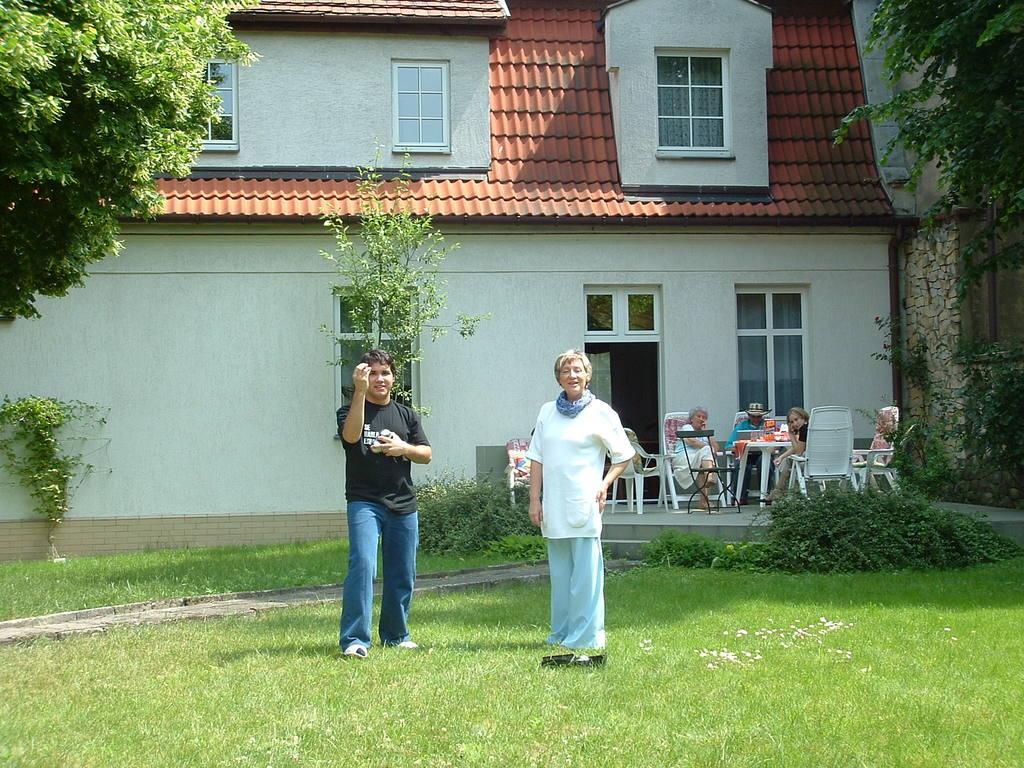Could you give a brief overview of what you see in this image? In this image we can see two persons are standing on the grass on the ground. In the background we can see two persons are sitting on the chairs at the table, building, windows, trees, plants and items on the table. 